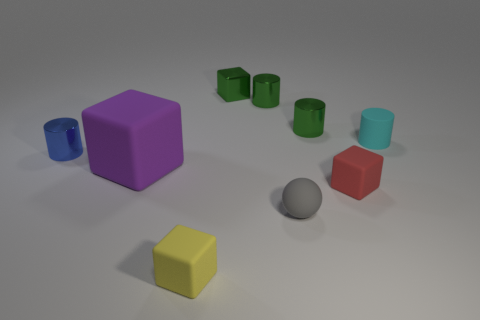Subtract 1 cylinders. How many cylinders are left? 3 Subtract all gray cubes. Subtract all brown cylinders. How many cubes are left? 4 Add 1 tiny yellow cubes. How many objects exist? 10 Subtract all balls. How many objects are left? 8 Add 5 cyan cylinders. How many cyan cylinders exist? 6 Subtract 1 red blocks. How many objects are left? 8 Subtract all shiny spheres. Subtract all small blue things. How many objects are left? 8 Add 6 tiny green metal things. How many tiny green metal things are left? 9 